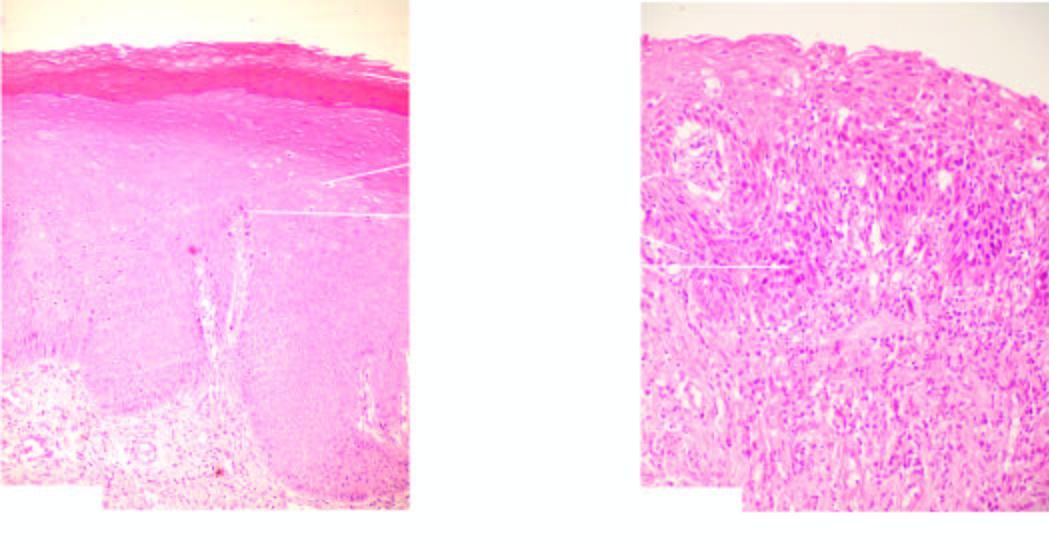what do the individual cells in layers show?
Answer the question using a single word or phrase. Features of cytologic atypia and mitosis 